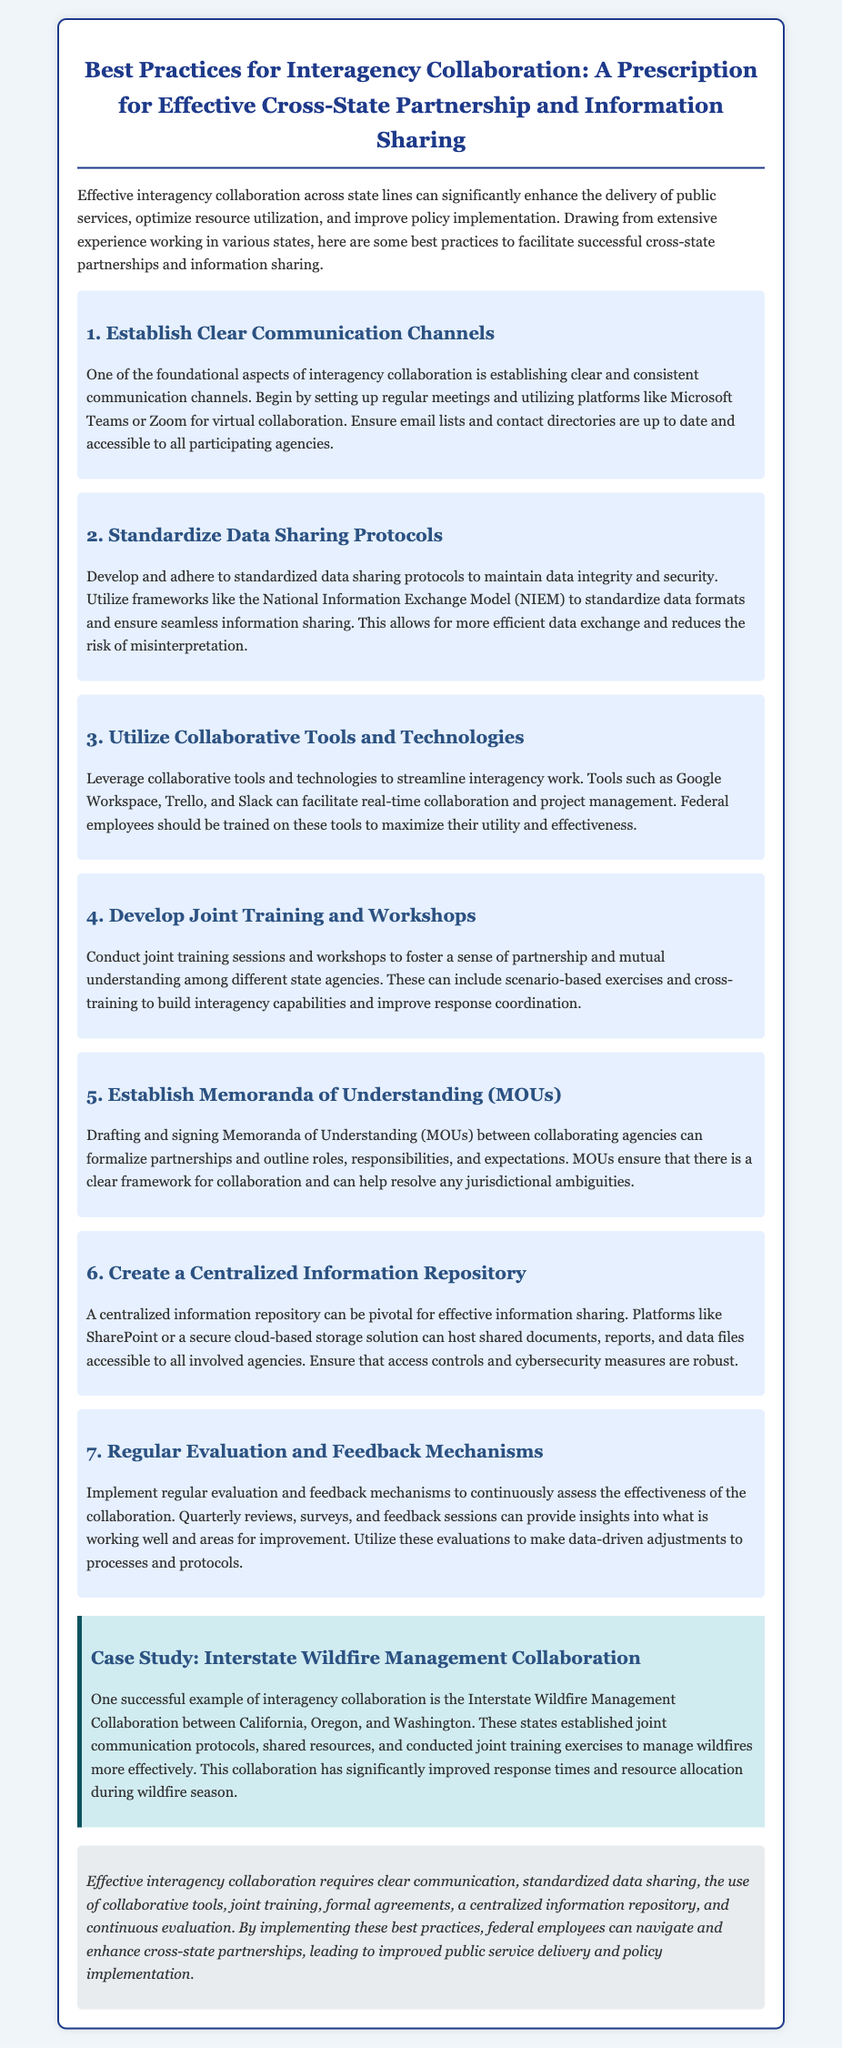What is the title of the prescription? The title is the main heading of the document, outlining its purpose and focus area.
Answer: Best Practices for Interagency Collaboration: A Prescription for Effective Cross-State Partnership and Information Sharing How many sections are there in the prescription? The document includes a main body of content divided into specific sections, each representing a best practice.
Answer: Seven What is one tool recommended for virtual collaboration? The document lists specific tools useful for collaboration in its sections, one of which is identified for virtual communication.
Answer: Microsoft Teams What does MOU stand for? The document explains the abbreviation for a key formal agreement that helps define roles and responsibilities in collaboration.
Answer: Memoranda of Understanding Which states were involved in the case study? The case study within the document highlights a specific collaboration among certain states for wildfire management.
Answer: California, Oregon, and Washington What is a key feature of a centralized information repository? The document emphasizes the importance of a centralized location for information sharing among agencies, highlighting its accessibility.
Answer: Accessible to all involved agencies What method is suggested for evaluating collaboration effectiveness? It mentions regular activities that should be conducted to assess how well the collaboration is working.
Answer: Quarterly reviews What is the primary purpose of the prescription? The overall aim of the document is to provide guidance on interagency collaboration, focusing on specific practices.
Answer: Enhance the delivery of public services 